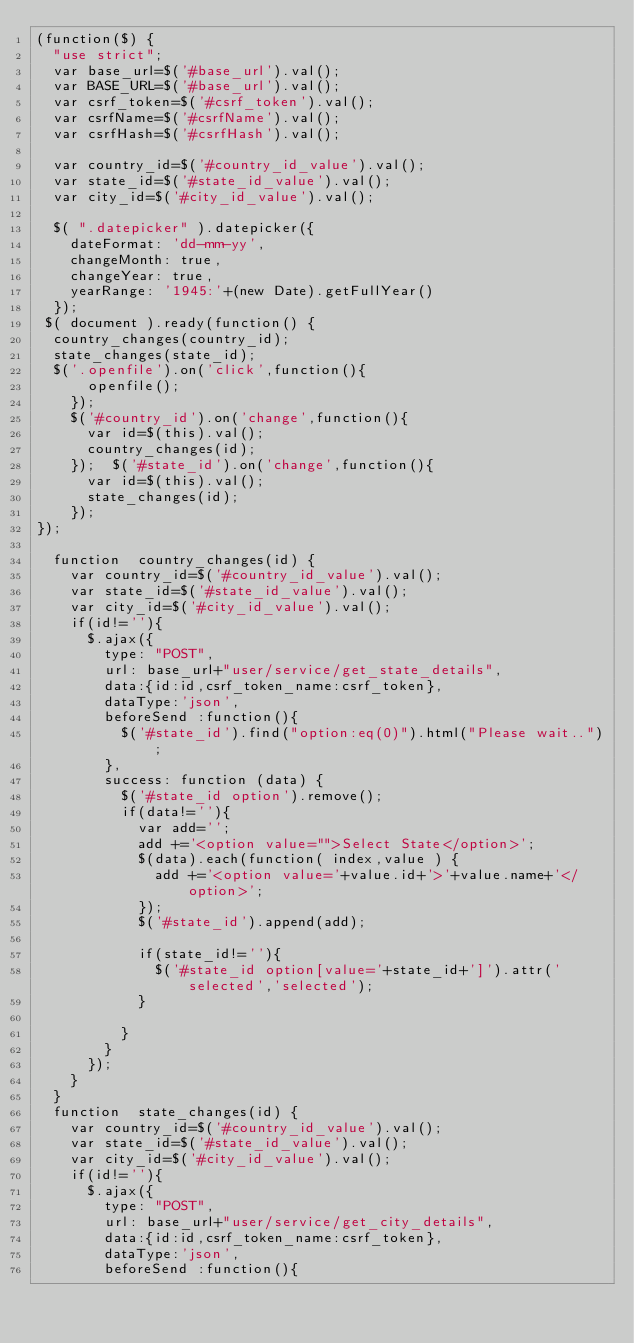<code> <loc_0><loc_0><loc_500><loc_500><_JavaScript_>(function($) {
	"use strict";
	var base_url=$('#base_url').val();
	var BASE_URL=$('#base_url').val();
	var csrf_token=$('#csrf_token').val();
	var csrfName=$('#csrfName').val();
	var csrfHash=$('#csrfHash').val();

	var country_id=$('#country_id_value').val();
	var state_id=$('#state_id_value').val();
	var city_id=$('#city_id_value').val();
	
	$( ".datepicker" ).datepicker({ 
		dateFormat: 'dd-mm-yy', 
		changeMonth: true, 
		changeYear: true,
		yearRange: '1945:'+(new Date).getFullYear() 
	}); 
 $( document ).ready(function() {
	country_changes(country_id);
	state_changes(state_id);
	$('.openfile').on('click',function(){
      openfile();
    }); 
    $('#country_id').on('change',function(){
     	var id=$(this).val();
      country_changes(id);
    });  $('#state_id').on('change',function(){
     	var id=$(this).val();
      state_changes(id);
    }); 
});

	function  country_changes(id) {
		var country_id=$('#country_id_value').val();
		var state_id=$('#state_id_value').val();
		var city_id=$('#city_id_value').val();
		if(id!=''){
			$.ajax({
				type: "POST",
				url: base_url+"user/service/get_state_details",
				data:{id:id,csrf_token_name:csrf_token}, 
				dataType:'json',
				beforeSend :function(){
					$('#state_id').find("option:eq(0)").html("Please wait..");
				}, 
				success: function (data) {
					$('#state_id option').remove();
					if(data!=''){
						var add='';
						add +='<option value="">Select State</option>';
						$(data).each(function( index,value ) {
							add +='<option value='+value.id+'>'+value.name+'</option>';
						});
						$('#state_id').append(add);

						if(state_id!=''){
							$('#state_id option[value='+state_id+']').attr('selected','selected');
						}

					}
				}
			});
		}
	}
	function  state_changes(id) { 
		var country_id=$('#country_id_value').val();
		var state_id=$('#state_id_value').val();
		var city_id=$('#city_id_value').val();
		if(id!=''){
			$.ajax({
				type: "POST",
				url: base_url+"user/service/get_city_details",
				data:{id:id,csrf_token_name:csrf_token}, 
				dataType:'json',
				beforeSend :function(){</code> 